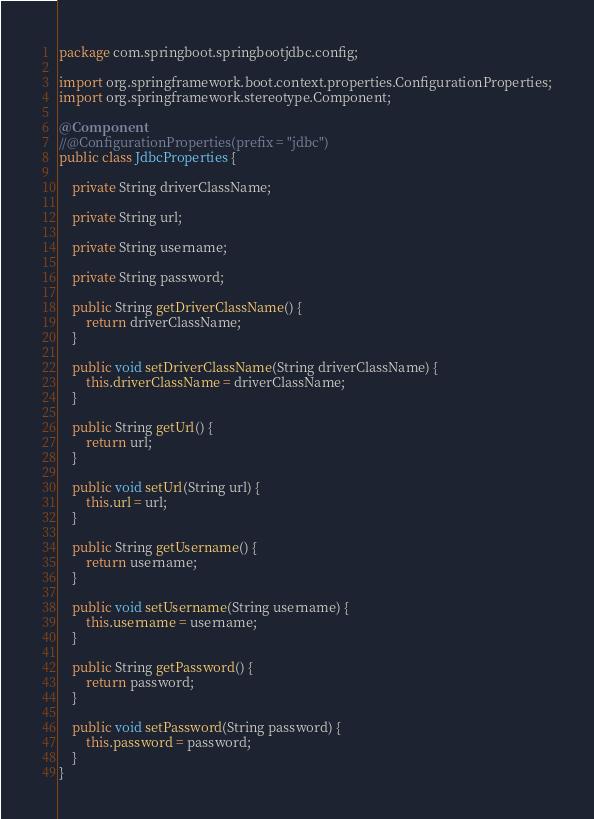<code> <loc_0><loc_0><loc_500><loc_500><_Java_>package com.springboot.springbootjdbc.config;

import org.springframework.boot.context.properties.ConfigurationProperties;
import org.springframework.stereotype.Component;

@Component
//@ConfigurationProperties(prefix = "jdbc")
public class JdbcProperties {

    private String driverClassName;

    private String url;

    private String username;

    private String password;

    public String getDriverClassName() {
        return driverClassName;
    }

    public void setDriverClassName(String driverClassName) {
        this.driverClassName = driverClassName;
    }

    public String getUrl() {
        return url;
    }

    public void setUrl(String url) {
        this.url = url;
    }

    public String getUsername() {
        return username;
    }

    public void setUsername(String username) {
        this.username = username;
    }

    public String getPassword() {
        return password;
    }

    public void setPassword(String password) {
        this.password = password;
    }
}
</code> 